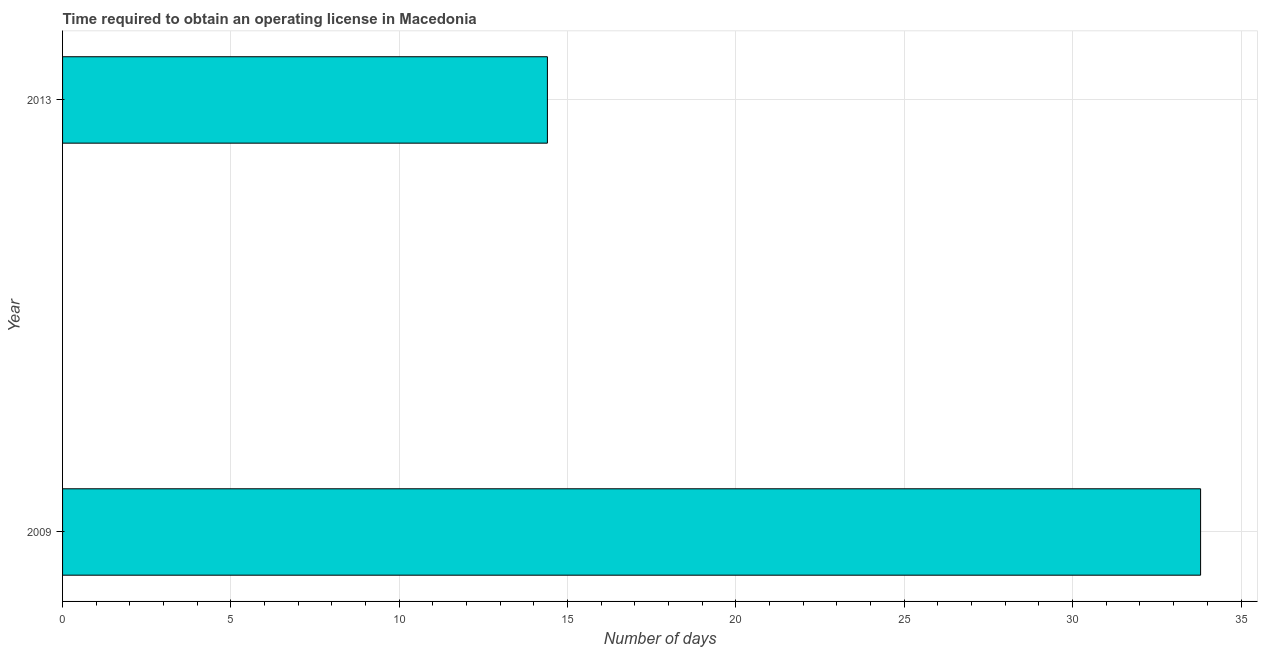Does the graph contain any zero values?
Make the answer very short. No. Does the graph contain grids?
Your answer should be compact. Yes. What is the title of the graph?
Provide a short and direct response. Time required to obtain an operating license in Macedonia. What is the label or title of the X-axis?
Provide a short and direct response. Number of days. What is the label or title of the Y-axis?
Keep it short and to the point. Year. What is the number of days to obtain operating license in 2013?
Keep it short and to the point. 14.4. Across all years, what is the maximum number of days to obtain operating license?
Keep it short and to the point. 33.8. Across all years, what is the minimum number of days to obtain operating license?
Your answer should be very brief. 14.4. In which year was the number of days to obtain operating license minimum?
Offer a terse response. 2013. What is the sum of the number of days to obtain operating license?
Offer a terse response. 48.2. What is the average number of days to obtain operating license per year?
Offer a very short reply. 24.1. What is the median number of days to obtain operating license?
Offer a very short reply. 24.1. What is the ratio of the number of days to obtain operating license in 2009 to that in 2013?
Make the answer very short. 2.35. Is the number of days to obtain operating license in 2009 less than that in 2013?
Give a very brief answer. No. In how many years, is the number of days to obtain operating license greater than the average number of days to obtain operating license taken over all years?
Your response must be concise. 1. How many bars are there?
Offer a terse response. 2. Are all the bars in the graph horizontal?
Your response must be concise. Yes. What is the difference between two consecutive major ticks on the X-axis?
Give a very brief answer. 5. What is the Number of days in 2009?
Your answer should be compact. 33.8. What is the Number of days of 2013?
Ensure brevity in your answer.  14.4. What is the difference between the Number of days in 2009 and 2013?
Your answer should be very brief. 19.4. What is the ratio of the Number of days in 2009 to that in 2013?
Make the answer very short. 2.35. 